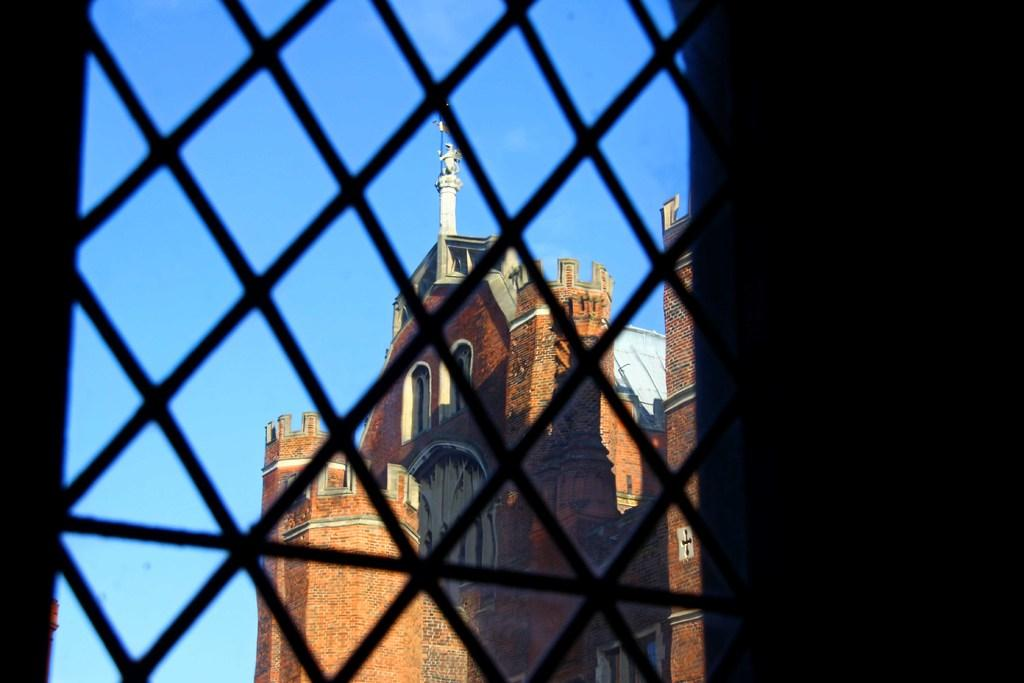What material is present in the image? There is mesh in the image. What can be seen through the mesh? A building is visible through the mesh. What color is the sky visible through the mesh? The sky visible through the mesh has a blue color. How does the right side of the image appear? The right side of the image appears dark. What type of brass door can be seen on the left side of the image? There is no brass door present in the image; it features mesh with a building and sky visible through it. 